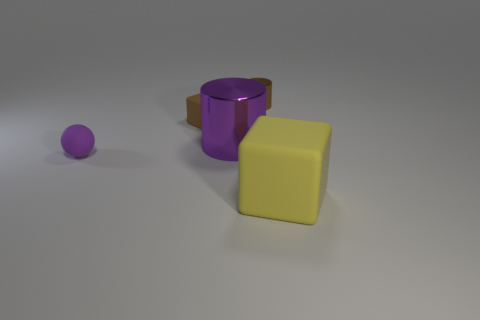How many other things are there of the same material as the tiny brown cylinder? There is one other object that appears to be made of the same matte material as the tiny brown cylinder. It is the larger yellow cube positioned to the right of the cylinder. 